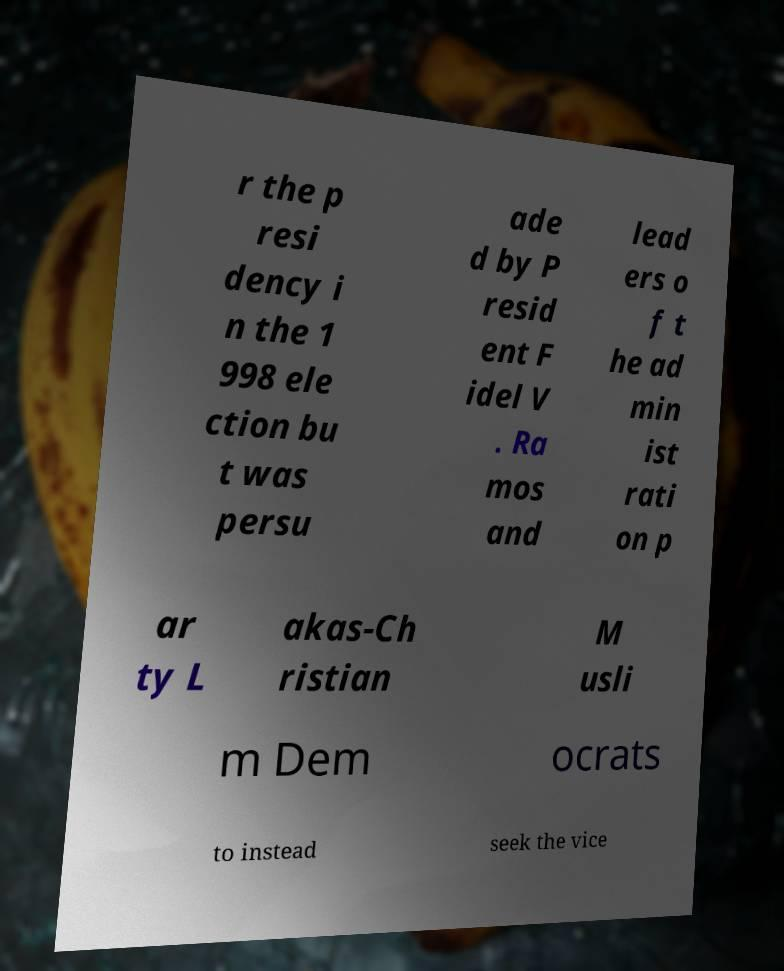Could you assist in decoding the text presented in this image and type it out clearly? r the p resi dency i n the 1 998 ele ction bu t was persu ade d by P resid ent F idel V . Ra mos and lead ers o f t he ad min ist rati on p ar ty L akas-Ch ristian M usli m Dem ocrats to instead seek the vice 